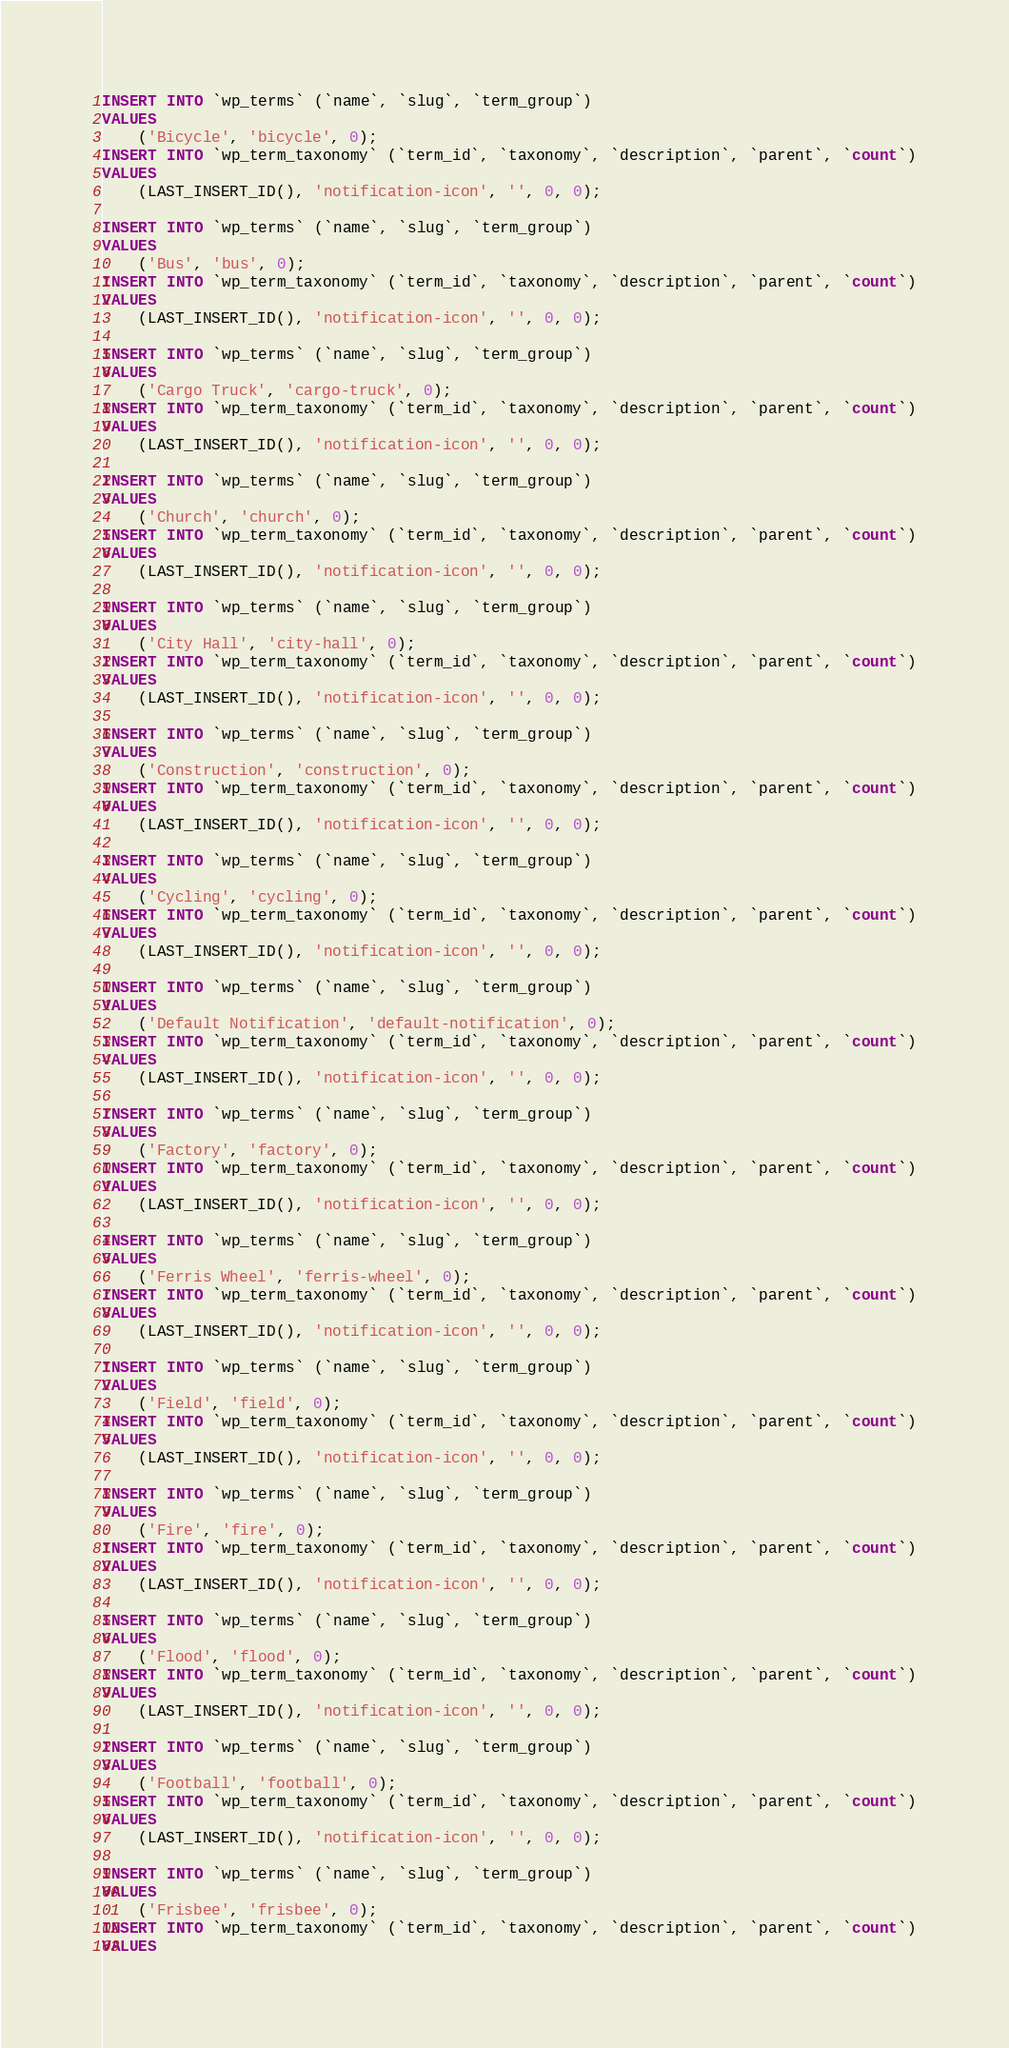<code> <loc_0><loc_0><loc_500><loc_500><_SQL_>
INSERT INTO `wp_terms` (`name`, `slug`, `term_group`)
VALUES
	('Bicycle', 'bicycle', 0);
INSERT INTO `wp_term_taxonomy` (`term_id`, `taxonomy`, `description`, `parent`, `count`)
VALUES
	(LAST_INSERT_ID(), 'notification-icon', '', 0, 0);

INSERT INTO `wp_terms` (`name`, `slug`, `term_group`)
VALUES
	('Bus', 'bus', 0);
INSERT INTO `wp_term_taxonomy` (`term_id`, `taxonomy`, `description`, `parent`, `count`)
VALUES
	(LAST_INSERT_ID(), 'notification-icon', '', 0, 0);

INSERT INTO `wp_terms` (`name`, `slug`, `term_group`)
VALUES
	('Cargo Truck', 'cargo-truck', 0);
INSERT INTO `wp_term_taxonomy` (`term_id`, `taxonomy`, `description`, `parent`, `count`)
VALUES
	(LAST_INSERT_ID(), 'notification-icon', '', 0, 0);

INSERT INTO `wp_terms` (`name`, `slug`, `term_group`)
VALUES
	('Church', 'church', 0);
INSERT INTO `wp_term_taxonomy` (`term_id`, `taxonomy`, `description`, `parent`, `count`)
VALUES
	(LAST_INSERT_ID(), 'notification-icon', '', 0, 0);

INSERT INTO `wp_terms` (`name`, `slug`, `term_group`)
VALUES
	('City Hall', 'city-hall', 0);
INSERT INTO `wp_term_taxonomy` (`term_id`, `taxonomy`, `description`, `parent`, `count`)
VALUES
	(LAST_INSERT_ID(), 'notification-icon', '', 0, 0);

INSERT INTO `wp_terms` (`name`, `slug`, `term_group`)
VALUES
	('Construction', 'construction', 0);
INSERT INTO `wp_term_taxonomy` (`term_id`, `taxonomy`, `description`, `parent`, `count`)
VALUES
	(LAST_INSERT_ID(), 'notification-icon', '', 0, 0);

INSERT INTO `wp_terms` (`name`, `slug`, `term_group`)
VALUES
	('Cycling', 'cycling', 0);
INSERT INTO `wp_term_taxonomy` (`term_id`, `taxonomy`, `description`, `parent`, `count`)
VALUES
	(LAST_INSERT_ID(), 'notification-icon', '', 0, 0);

INSERT INTO `wp_terms` (`name`, `slug`, `term_group`)
VALUES
	('Default Notification', 'default-notification', 0);
INSERT INTO `wp_term_taxonomy` (`term_id`, `taxonomy`, `description`, `parent`, `count`)
VALUES
	(LAST_INSERT_ID(), 'notification-icon', '', 0, 0);

INSERT INTO `wp_terms` (`name`, `slug`, `term_group`)
VALUES
	('Factory', 'factory', 0);
INSERT INTO `wp_term_taxonomy` (`term_id`, `taxonomy`, `description`, `parent`, `count`)
VALUES
	(LAST_INSERT_ID(), 'notification-icon', '', 0, 0);

INSERT INTO `wp_terms` (`name`, `slug`, `term_group`)
VALUES
	('Ferris Wheel', 'ferris-wheel', 0);
INSERT INTO `wp_term_taxonomy` (`term_id`, `taxonomy`, `description`, `parent`, `count`)
VALUES
	(LAST_INSERT_ID(), 'notification-icon', '', 0, 0);

INSERT INTO `wp_terms` (`name`, `slug`, `term_group`)
VALUES
	('Field', 'field', 0);
INSERT INTO `wp_term_taxonomy` (`term_id`, `taxonomy`, `description`, `parent`, `count`)
VALUES
	(LAST_INSERT_ID(), 'notification-icon', '', 0, 0);

INSERT INTO `wp_terms` (`name`, `slug`, `term_group`)
VALUES
	('Fire', 'fire', 0);
INSERT INTO `wp_term_taxonomy` (`term_id`, `taxonomy`, `description`, `parent`, `count`)
VALUES
	(LAST_INSERT_ID(), 'notification-icon', '', 0, 0);

INSERT INTO `wp_terms` (`name`, `slug`, `term_group`)
VALUES
	('Flood', 'flood', 0);
INSERT INTO `wp_term_taxonomy` (`term_id`, `taxonomy`, `description`, `parent`, `count`)
VALUES
	(LAST_INSERT_ID(), 'notification-icon', '', 0, 0);

INSERT INTO `wp_terms` (`name`, `slug`, `term_group`)
VALUES
	('Football', 'football', 0);
INSERT INTO `wp_term_taxonomy` (`term_id`, `taxonomy`, `description`, `parent`, `count`)
VALUES
	(LAST_INSERT_ID(), 'notification-icon', '', 0, 0);

INSERT INTO `wp_terms` (`name`, `slug`, `term_group`)
VALUES
	('Frisbee', 'frisbee', 0);
INSERT INTO `wp_term_taxonomy` (`term_id`, `taxonomy`, `description`, `parent`, `count`)
VALUES</code> 